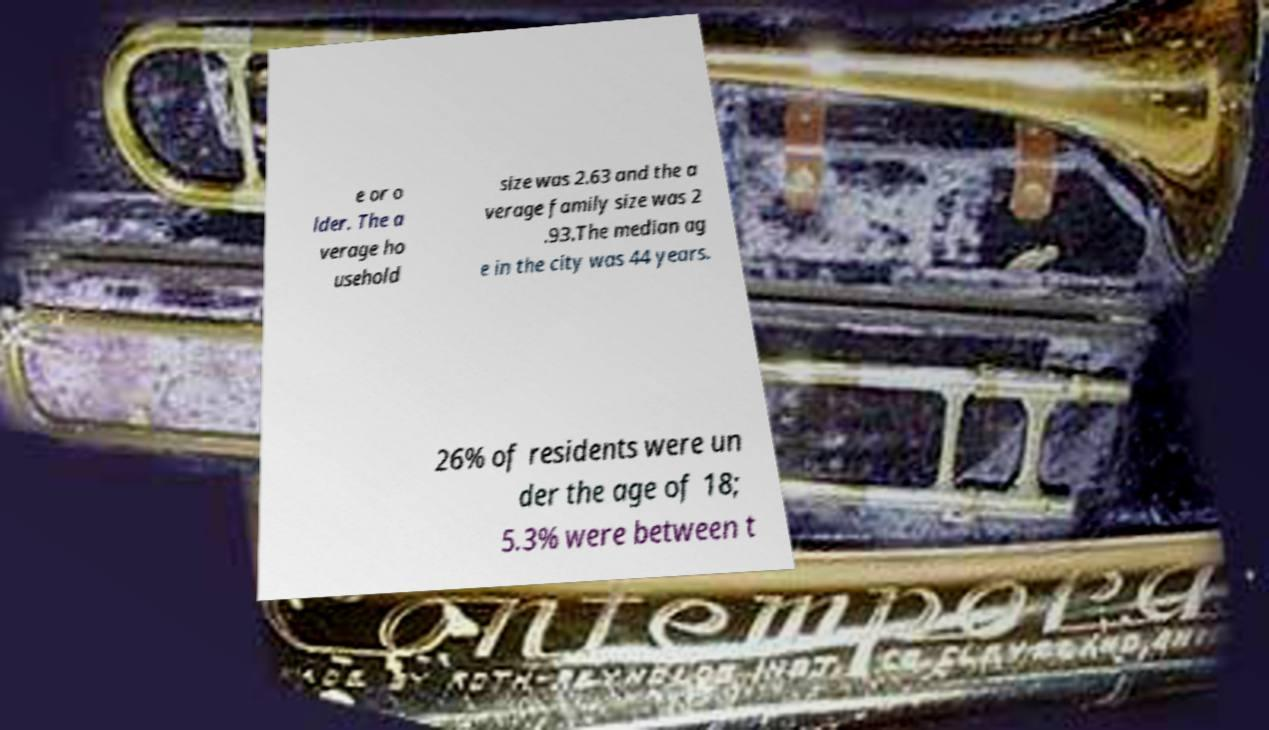There's text embedded in this image that I need extracted. Can you transcribe it verbatim? e or o lder. The a verage ho usehold size was 2.63 and the a verage family size was 2 .93.The median ag e in the city was 44 years. 26% of residents were un der the age of 18; 5.3% were between t 